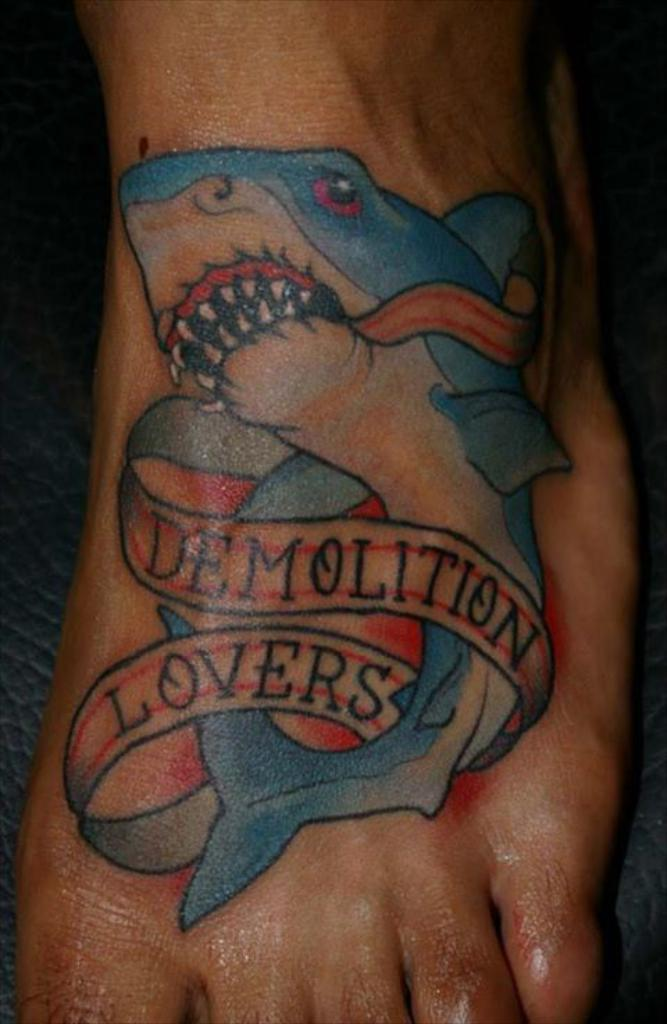What part of the body is visible in the image? There is a person's leg in the image. What is depicted on the leg? There is a fish tattoo on the leg. What colors are used in the tattoo? The tattoo has blue, red, and black colors. What type of beetle can be seen crawling on the person's leg in the image? There is no beetle present on the person's leg in the image; it only features a fish tattoo. 